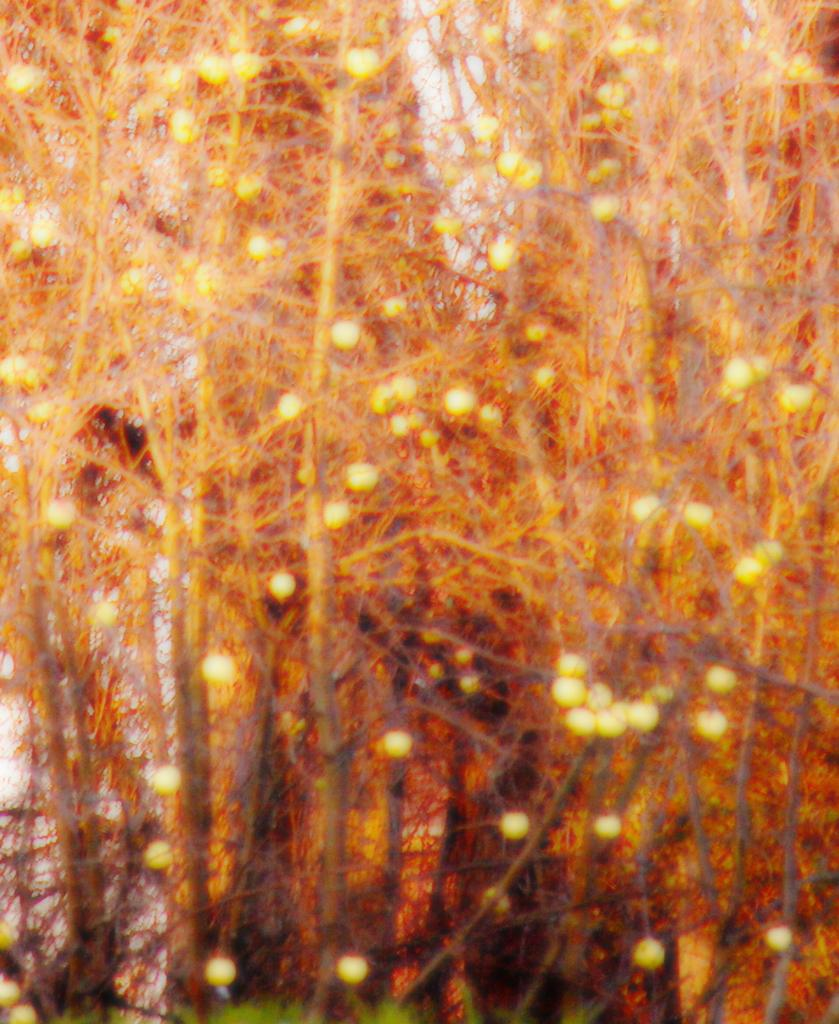What type of natural elements can be seen in the image? There are trees in the image. What else can be seen in the image besides the trees? There are lights visible in the image. Where are the cows located in the image? There are no cows present in the image. What type of amusement can be seen in the image? There is no amusement depicted in the image; it features trees and lights. 